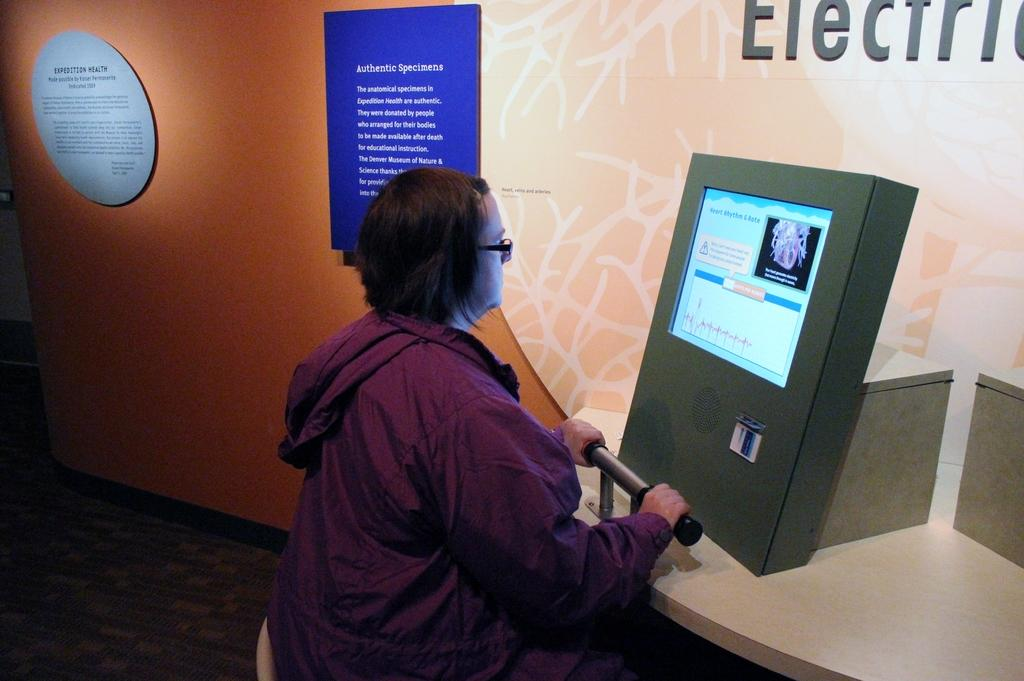What is the person in the image doing? The person is sitting on a chair in the image. What is in front of the person? The person is in front of a display screen. What can be seen on the wall in the background of the image? There are information boards on the wall in the background of the image. What month is it in the image? The month cannot be determined from the image, as there is no information about the date or time. 